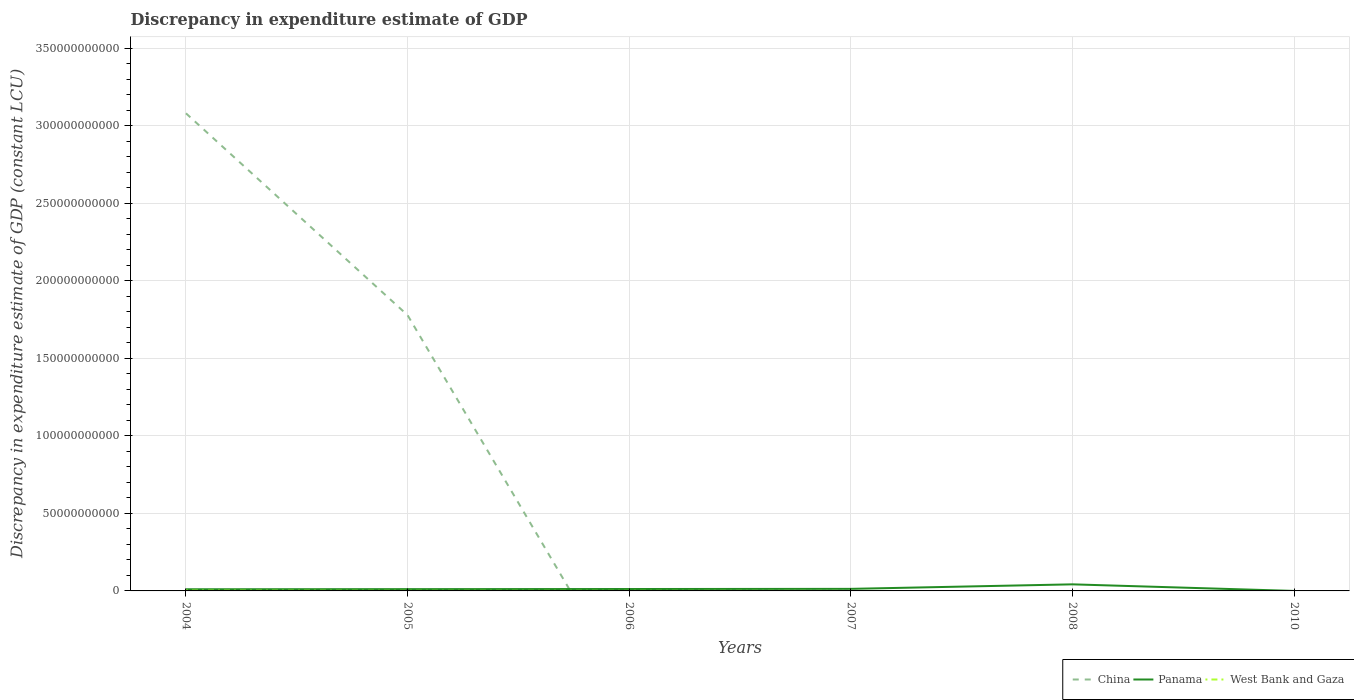Does the line corresponding to West Bank and Gaza intersect with the line corresponding to Panama?
Provide a succinct answer. No. Across all years, what is the maximum discrepancy in expenditure estimate of GDP in China?
Your answer should be very brief. 0. What is the total discrepancy in expenditure estimate of GDP in Panama in the graph?
Offer a terse response. -7.95e+07. What is the difference between the highest and the second highest discrepancy in expenditure estimate of GDP in Panama?
Offer a very short reply. 4.24e+09. How many years are there in the graph?
Offer a terse response. 6. What is the difference between two consecutive major ticks on the Y-axis?
Your answer should be compact. 5.00e+1. Does the graph contain any zero values?
Keep it short and to the point. Yes. Does the graph contain grids?
Your answer should be very brief. Yes. What is the title of the graph?
Your answer should be compact. Discrepancy in expenditure estimate of GDP. Does "Guinea" appear as one of the legend labels in the graph?
Your answer should be very brief. No. What is the label or title of the Y-axis?
Provide a short and direct response. Discrepancy in expenditure estimate of GDP (constant LCU). What is the Discrepancy in expenditure estimate of GDP (constant LCU) of China in 2004?
Provide a short and direct response. 3.08e+11. What is the Discrepancy in expenditure estimate of GDP (constant LCU) of Panama in 2004?
Keep it short and to the point. 1.07e+09. What is the Discrepancy in expenditure estimate of GDP (constant LCU) in West Bank and Gaza in 2004?
Your response must be concise. 2.07e+08. What is the Discrepancy in expenditure estimate of GDP (constant LCU) of China in 2005?
Keep it short and to the point. 1.78e+11. What is the Discrepancy in expenditure estimate of GDP (constant LCU) in Panama in 2005?
Offer a terse response. 1.15e+09. What is the Discrepancy in expenditure estimate of GDP (constant LCU) of West Bank and Gaza in 2005?
Ensure brevity in your answer.  6.51e+07. What is the Discrepancy in expenditure estimate of GDP (constant LCU) of China in 2006?
Make the answer very short. 0. What is the Discrepancy in expenditure estimate of GDP (constant LCU) in Panama in 2006?
Offer a terse response. 1.23e+09. What is the Discrepancy in expenditure estimate of GDP (constant LCU) of West Bank and Gaza in 2006?
Keep it short and to the point. 4.10e+07. What is the Discrepancy in expenditure estimate of GDP (constant LCU) of Panama in 2007?
Your answer should be very brief. 1.33e+09. What is the Discrepancy in expenditure estimate of GDP (constant LCU) in Panama in 2008?
Your answer should be very brief. 4.24e+09. What is the Discrepancy in expenditure estimate of GDP (constant LCU) of West Bank and Gaza in 2008?
Make the answer very short. 0. What is the Discrepancy in expenditure estimate of GDP (constant LCU) of Panama in 2010?
Give a very brief answer. 0. Across all years, what is the maximum Discrepancy in expenditure estimate of GDP (constant LCU) in China?
Ensure brevity in your answer.  3.08e+11. Across all years, what is the maximum Discrepancy in expenditure estimate of GDP (constant LCU) of Panama?
Your response must be concise. 4.24e+09. Across all years, what is the maximum Discrepancy in expenditure estimate of GDP (constant LCU) in West Bank and Gaza?
Your answer should be compact. 2.07e+08. Across all years, what is the minimum Discrepancy in expenditure estimate of GDP (constant LCU) in West Bank and Gaza?
Keep it short and to the point. 0. What is the total Discrepancy in expenditure estimate of GDP (constant LCU) in China in the graph?
Offer a very short reply. 4.86e+11. What is the total Discrepancy in expenditure estimate of GDP (constant LCU) of Panama in the graph?
Make the answer very short. 9.02e+09. What is the total Discrepancy in expenditure estimate of GDP (constant LCU) in West Bank and Gaza in the graph?
Give a very brief answer. 3.13e+08. What is the difference between the Discrepancy in expenditure estimate of GDP (constant LCU) in China in 2004 and that in 2005?
Your answer should be compact. 1.30e+11. What is the difference between the Discrepancy in expenditure estimate of GDP (constant LCU) of Panama in 2004 and that in 2005?
Your answer should be compact. -7.95e+07. What is the difference between the Discrepancy in expenditure estimate of GDP (constant LCU) of West Bank and Gaza in 2004 and that in 2005?
Ensure brevity in your answer.  1.41e+08. What is the difference between the Discrepancy in expenditure estimate of GDP (constant LCU) in Panama in 2004 and that in 2006?
Provide a short and direct response. -1.61e+08. What is the difference between the Discrepancy in expenditure estimate of GDP (constant LCU) in West Bank and Gaza in 2004 and that in 2006?
Your answer should be very brief. 1.65e+08. What is the difference between the Discrepancy in expenditure estimate of GDP (constant LCU) in Panama in 2004 and that in 2007?
Offer a terse response. -2.58e+08. What is the difference between the Discrepancy in expenditure estimate of GDP (constant LCU) of Panama in 2004 and that in 2008?
Offer a terse response. -3.17e+09. What is the difference between the Discrepancy in expenditure estimate of GDP (constant LCU) in Panama in 2005 and that in 2006?
Offer a terse response. -8.14e+07. What is the difference between the Discrepancy in expenditure estimate of GDP (constant LCU) in West Bank and Gaza in 2005 and that in 2006?
Your answer should be compact. 2.41e+07. What is the difference between the Discrepancy in expenditure estimate of GDP (constant LCU) of Panama in 2005 and that in 2007?
Your answer should be compact. -1.78e+08. What is the difference between the Discrepancy in expenditure estimate of GDP (constant LCU) of Panama in 2005 and that in 2008?
Your response must be concise. -3.09e+09. What is the difference between the Discrepancy in expenditure estimate of GDP (constant LCU) of Panama in 2006 and that in 2007?
Your answer should be compact. -9.70e+07. What is the difference between the Discrepancy in expenditure estimate of GDP (constant LCU) in Panama in 2006 and that in 2008?
Your answer should be compact. -3.01e+09. What is the difference between the Discrepancy in expenditure estimate of GDP (constant LCU) in Panama in 2007 and that in 2008?
Make the answer very short. -2.91e+09. What is the difference between the Discrepancy in expenditure estimate of GDP (constant LCU) in China in 2004 and the Discrepancy in expenditure estimate of GDP (constant LCU) in Panama in 2005?
Your answer should be compact. 3.07e+11. What is the difference between the Discrepancy in expenditure estimate of GDP (constant LCU) of China in 2004 and the Discrepancy in expenditure estimate of GDP (constant LCU) of West Bank and Gaza in 2005?
Offer a terse response. 3.08e+11. What is the difference between the Discrepancy in expenditure estimate of GDP (constant LCU) in Panama in 2004 and the Discrepancy in expenditure estimate of GDP (constant LCU) in West Bank and Gaza in 2005?
Your response must be concise. 1.01e+09. What is the difference between the Discrepancy in expenditure estimate of GDP (constant LCU) in China in 2004 and the Discrepancy in expenditure estimate of GDP (constant LCU) in Panama in 2006?
Keep it short and to the point. 3.07e+11. What is the difference between the Discrepancy in expenditure estimate of GDP (constant LCU) of China in 2004 and the Discrepancy in expenditure estimate of GDP (constant LCU) of West Bank and Gaza in 2006?
Provide a succinct answer. 3.08e+11. What is the difference between the Discrepancy in expenditure estimate of GDP (constant LCU) in Panama in 2004 and the Discrepancy in expenditure estimate of GDP (constant LCU) in West Bank and Gaza in 2006?
Ensure brevity in your answer.  1.03e+09. What is the difference between the Discrepancy in expenditure estimate of GDP (constant LCU) of China in 2004 and the Discrepancy in expenditure estimate of GDP (constant LCU) of Panama in 2007?
Make the answer very short. 3.07e+11. What is the difference between the Discrepancy in expenditure estimate of GDP (constant LCU) of China in 2004 and the Discrepancy in expenditure estimate of GDP (constant LCU) of Panama in 2008?
Provide a succinct answer. 3.04e+11. What is the difference between the Discrepancy in expenditure estimate of GDP (constant LCU) in China in 2005 and the Discrepancy in expenditure estimate of GDP (constant LCU) in Panama in 2006?
Your response must be concise. 1.77e+11. What is the difference between the Discrepancy in expenditure estimate of GDP (constant LCU) in China in 2005 and the Discrepancy in expenditure estimate of GDP (constant LCU) in West Bank and Gaza in 2006?
Give a very brief answer. 1.78e+11. What is the difference between the Discrepancy in expenditure estimate of GDP (constant LCU) of Panama in 2005 and the Discrepancy in expenditure estimate of GDP (constant LCU) of West Bank and Gaza in 2006?
Offer a very short reply. 1.11e+09. What is the difference between the Discrepancy in expenditure estimate of GDP (constant LCU) in China in 2005 and the Discrepancy in expenditure estimate of GDP (constant LCU) in Panama in 2007?
Give a very brief answer. 1.77e+11. What is the difference between the Discrepancy in expenditure estimate of GDP (constant LCU) in China in 2005 and the Discrepancy in expenditure estimate of GDP (constant LCU) in Panama in 2008?
Your response must be concise. 1.74e+11. What is the average Discrepancy in expenditure estimate of GDP (constant LCU) of China per year?
Keep it short and to the point. 8.10e+1. What is the average Discrepancy in expenditure estimate of GDP (constant LCU) in Panama per year?
Offer a terse response. 1.50e+09. What is the average Discrepancy in expenditure estimate of GDP (constant LCU) in West Bank and Gaza per year?
Your response must be concise. 5.21e+07. In the year 2004, what is the difference between the Discrepancy in expenditure estimate of GDP (constant LCU) of China and Discrepancy in expenditure estimate of GDP (constant LCU) of Panama?
Your answer should be compact. 3.07e+11. In the year 2004, what is the difference between the Discrepancy in expenditure estimate of GDP (constant LCU) of China and Discrepancy in expenditure estimate of GDP (constant LCU) of West Bank and Gaza?
Make the answer very short. 3.08e+11. In the year 2004, what is the difference between the Discrepancy in expenditure estimate of GDP (constant LCU) of Panama and Discrepancy in expenditure estimate of GDP (constant LCU) of West Bank and Gaza?
Your response must be concise. 8.64e+08. In the year 2005, what is the difference between the Discrepancy in expenditure estimate of GDP (constant LCU) in China and Discrepancy in expenditure estimate of GDP (constant LCU) in Panama?
Provide a short and direct response. 1.77e+11. In the year 2005, what is the difference between the Discrepancy in expenditure estimate of GDP (constant LCU) of China and Discrepancy in expenditure estimate of GDP (constant LCU) of West Bank and Gaza?
Your answer should be compact. 1.78e+11. In the year 2005, what is the difference between the Discrepancy in expenditure estimate of GDP (constant LCU) of Panama and Discrepancy in expenditure estimate of GDP (constant LCU) of West Bank and Gaza?
Offer a very short reply. 1.08e+09. In the year 2006, what is the difference between the Discrepancy in expenditure estimate of GDP (constant LCU) of Panama and Discrepancy in expenditure estimate of GDP (constant LCU) of West Bank and Gaza?
Give a very brief answer. 1.19e+09. What is the ratio of the Discrepancy in expenditure estimate of GDP (constant LCU) in China in 2004 to that in 2005?
Ensure brevity in your answer.  1.73. What is the ratio of the Discrepancy in expenditure estimate of GDP (constant LCU) in Panama in 2004 to that in 2005?
Provide a short and direct response. 0.93. What is the ratio of the Discrepancy in expenditure estimate of GDP (constant LCU) in West Bank and Gaza in 2004 to that in 2005?
Your answer should be compact. 3.17. What is the ratio of the Discrepancy in expenditure estimate of GDP (constant LCU) of Panama in 2004 to that in 2006?
Keep it short and to the point. 0.87. What is the ratio of the Discrepancy in expenditure estimate of GDP (constant LCU) in West Bank and Gaza in 2004 to that in 2006?
Your response must be concise. 5.03. What is the ratio of the Discrepancy in expenditure estimate of GDP (constant LCU) in Panama in 2004 to that in 2007?
Your answer should be compact. 0.81. What is the ratio of the Discrepancy in expenditure estimate of GDP (constant LCU) of Panama in 2004 to that in 2008?
Provide a succinct answer. 0.25. What is the ratio of the Discrepancy in expenditure estimate of GDP (constant LCU) in Panama in 2005 to that in 2006?
Ensure brevity in your answer.  0.93. What is the ratio of the Discrepancy in expenditure estimate of GDP (constant LCU) of West Bank and Gaza in 2005 to that in 2006?
Give a very brief answer. 1.59. What is the ratio of the Discrepancy in expenditure estimate of GDP (constant LCU) of Panama in 2005 to that in 2007?
Provide a short and direct response. 0.87. What is the ratio of the Discrepancy in expenditure estimate of GDP (constant LCU) in Panama in 2005 to that in 2008?
Provide a short and direct response. 0.27. What is the ratio of the Discrepancy in expenditure estimate of GDP (constant LCU) in Panama in 2006 to that in 2007?
Your answer should be very brief. 0.93. What is the ratio of the Discrepancy in expenditure estimate of GDP (constant LCU) in Panama in 2006 to that in 2008?
Provide a short and direct response. 0.29. What is the ratio of the Discrepancy in expenditure estimate of GDP (constant LCU) of Panama in 2007 to that in 2008?
Offer a terse response. 0.31. What is the difference between the highest and the second highest Discrepancy in expenditure estimate of GDP (constant LCU) of Panama?
Keep it short and to the point. 2.91e+09. What is the difference between the highest and the second highest Discrepancy in expenditure estimate of GDP (constant LCU) of West Bank and Gaza?
Provide a short and direct response. 1.41e+08. What is the difference between the highest and the lowest Discrepancy in expenditure estimate of GDP (constant LCU) in China?
Your response must be concise. 3.08e+11. What is the difference between the highest and the lowest Discrepancy in expenditure estimate of GDP (constant LCU) of Panama?
Keep it short and to the point. 4.24e+09. What is the difference between the highest and the lowest Discrepancy in expenditure estimate of GDP (constant LCU) of West Bank and Gaza?
Make the answer very short. 2.07e+08. 